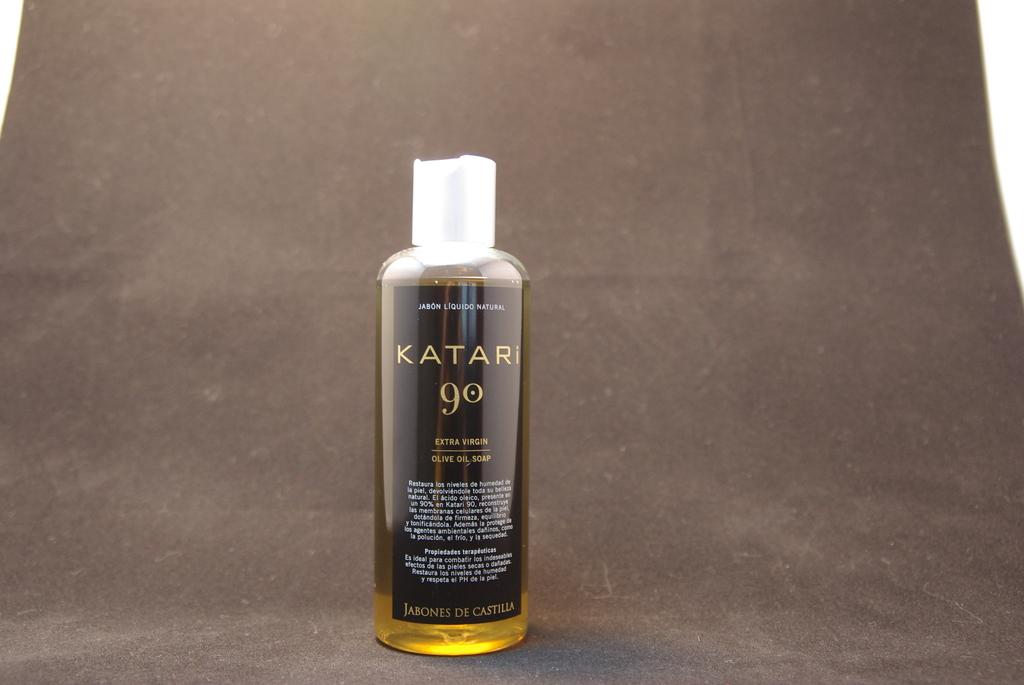<image>
Give a short and clear explanation of the subsequent image. The bottle of Katari extra virgin olive oil has a black label. 